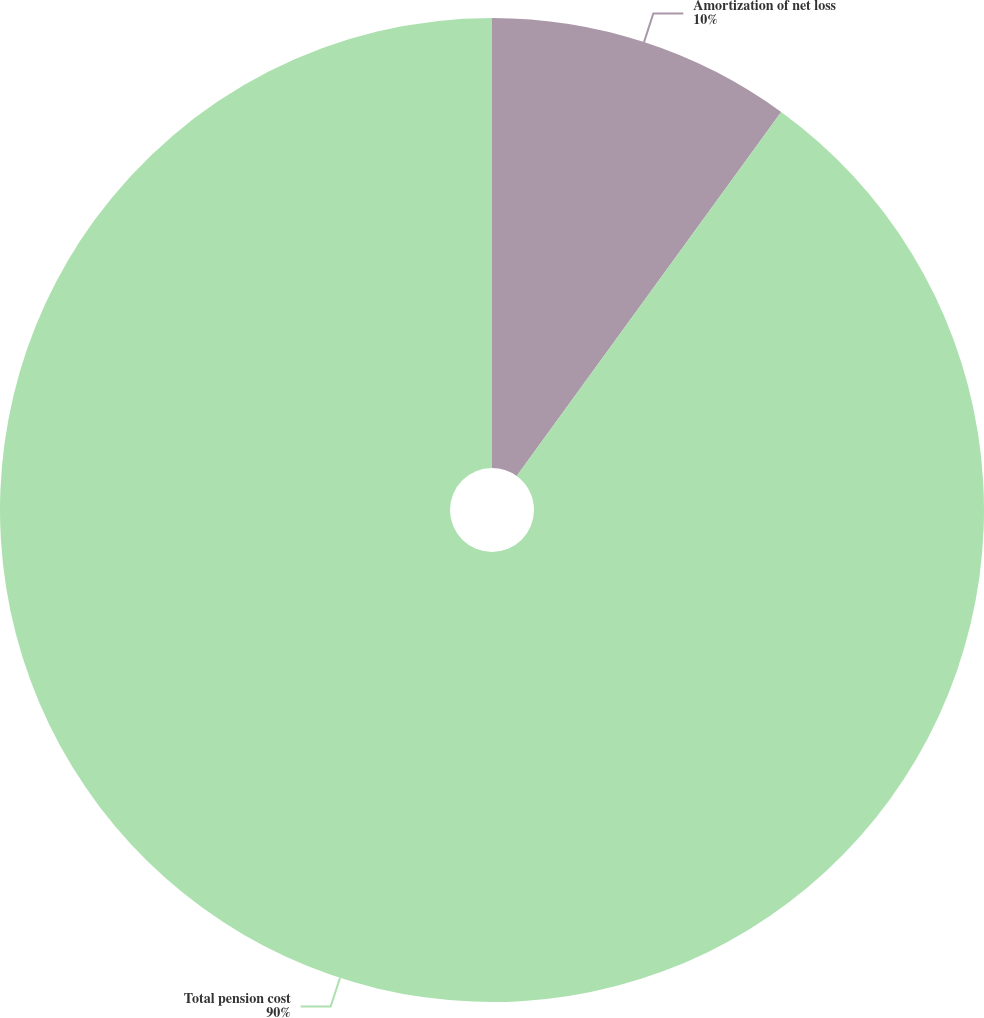Convert chart. <chart><loc_0><loc_0><loc_500><loc_500><pie_chart><fcel>Amortization of net loss<fcel>Total pension cost<nl><fcel>10.0%<fcel>90.0%<nl></chart> 